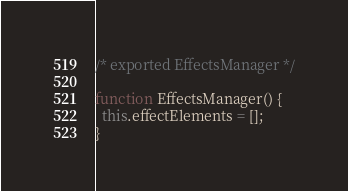<code> <loc_0><loc_0><loc_500><loc_500><_JavaScript_>/* exported EffectsManager */

function EffectsManager() {
  this.effectElements = [];
}
</code> 